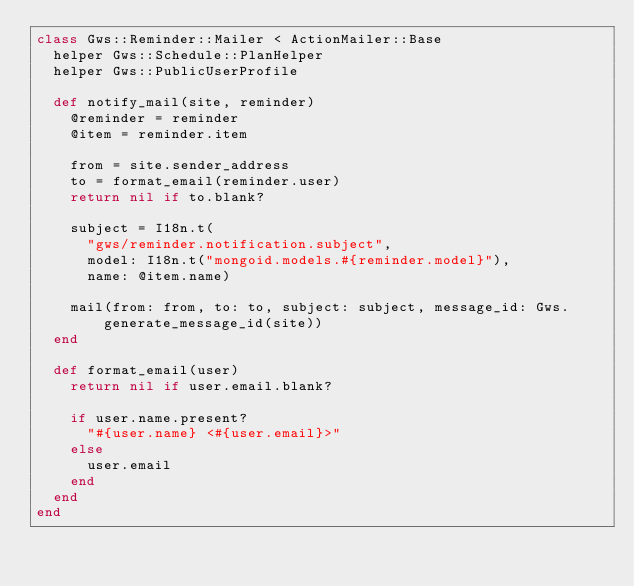Convert code to text. <code><loc_0><loc_0><loc_500><loc_500><_Ruby_>class Gws::Reminder::Mailer < ActionMailer::Base
  helper Gws::Schedule::PlanHelper
  helper Gws::PublicUserProfile

  def notify_mail(site, reminder)
    @reminder = reminder
    @item = reminder.item

    from = site.sender_address
    to = format_email(reminder.user)
    return nil if to.blank?

    subject = I18n.t(
      "gws/reminder.notification.subject",
      model: I18n.t("mongoid.models.#{reminder.model}"),
      name: @item.name)

    mail(from: from, to: to, subject: subject, message_id: Gws.generate_message_id(site))
  end

  def format_email(user)
    return nil if user.email.blank?

    if user.name.present?
      "#{user.name} <#{user.email}>"
    else
      user.email
    end
  end
end
</code> 